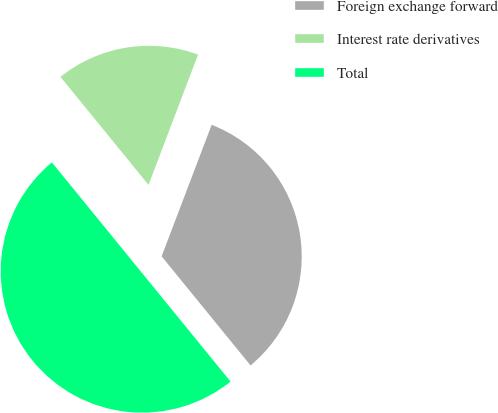Convert chart. <chart><loc_0><loc_0><loc_500><loc_500><pie_chart><fcel>Foreign exchange forward<fcel>Interest rate derivatives<fcel>Total<nl><fcel>33.33%<fcel>16.67%<fcel>50.0%<nl></chart> 